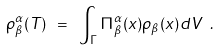Convert formula to latex. <formula><loc_0><loc_0><loc_500><loc_500>\rho ^ { \alpha } _ { \beta } ( T ) \ = \ \int _ { \sl \Gamma } \Pi ^ { \alpha } _ { \beta } ( x ) \rho _ { \beta } ( x ) d V \ .</formula> 